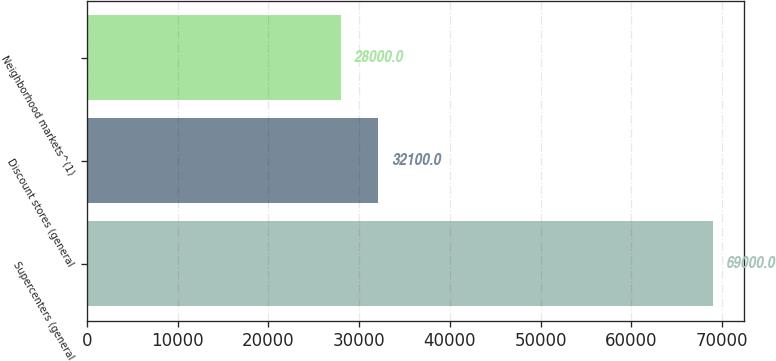Convert chart. <chart><loc_0><loc_0><loc_500><loc_500><bar_chart><fcel>Supercenters (general<fcel>Discount stores (general<fcel>Neighborhood markets^(1)<nl><fcel>69000<fcel>32100<fcel>28000<nl></chart> 